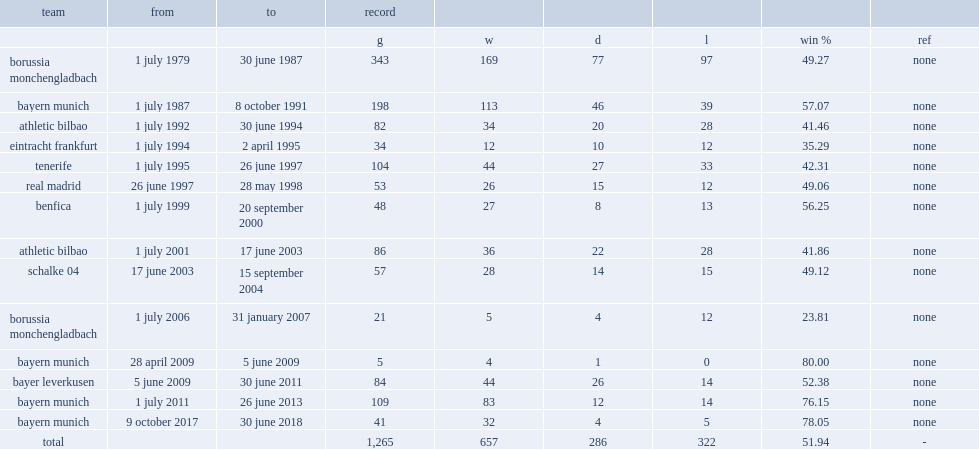When did jupp heynckes become the manager of eintracht frankfurt? 1 july 1994. 